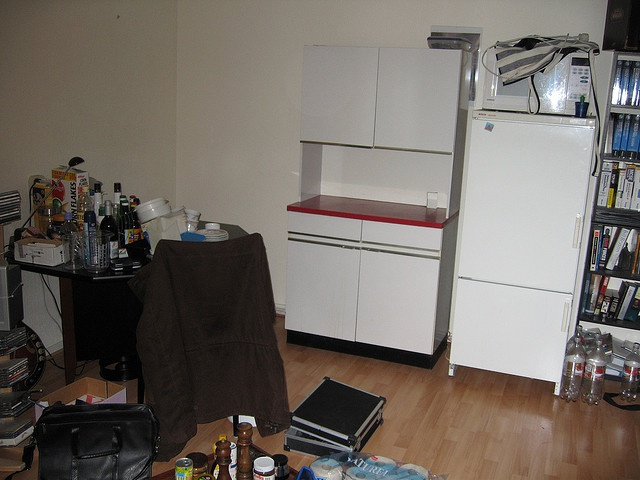Describe the objects in this image and their specific colors. I can see refrigerator in black, lightgray, and darkgray tones, chair in black, maroon, and gray tones, book in black, gray, darkgray, and navy tones, handbag in black, gray, and maroon tones, and suitcase in black, gray, and maroon tones in this image. 